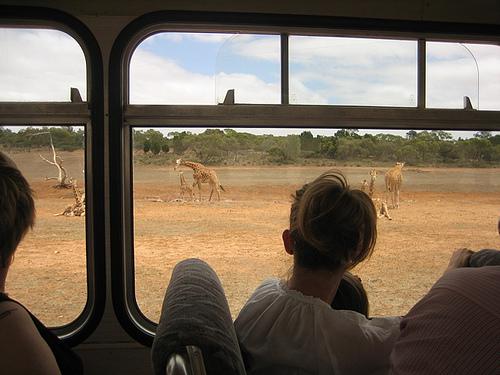How many giraffes can you count?
Short answer required. 6. What are the people looking at?
Write a very short answer. Giraffes. What are these people riding in?
Give a very brief answer. Bus. 